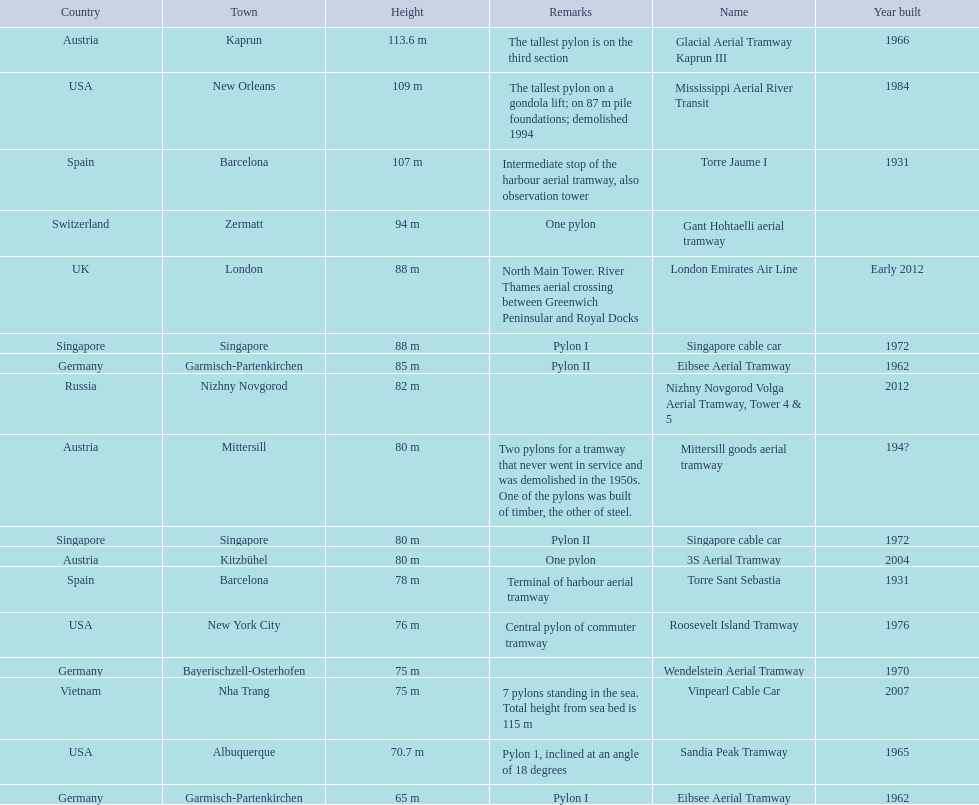Which lift has the second highest height? Mississippi Aerial River Transit. What is the value of the height? 109 m. 